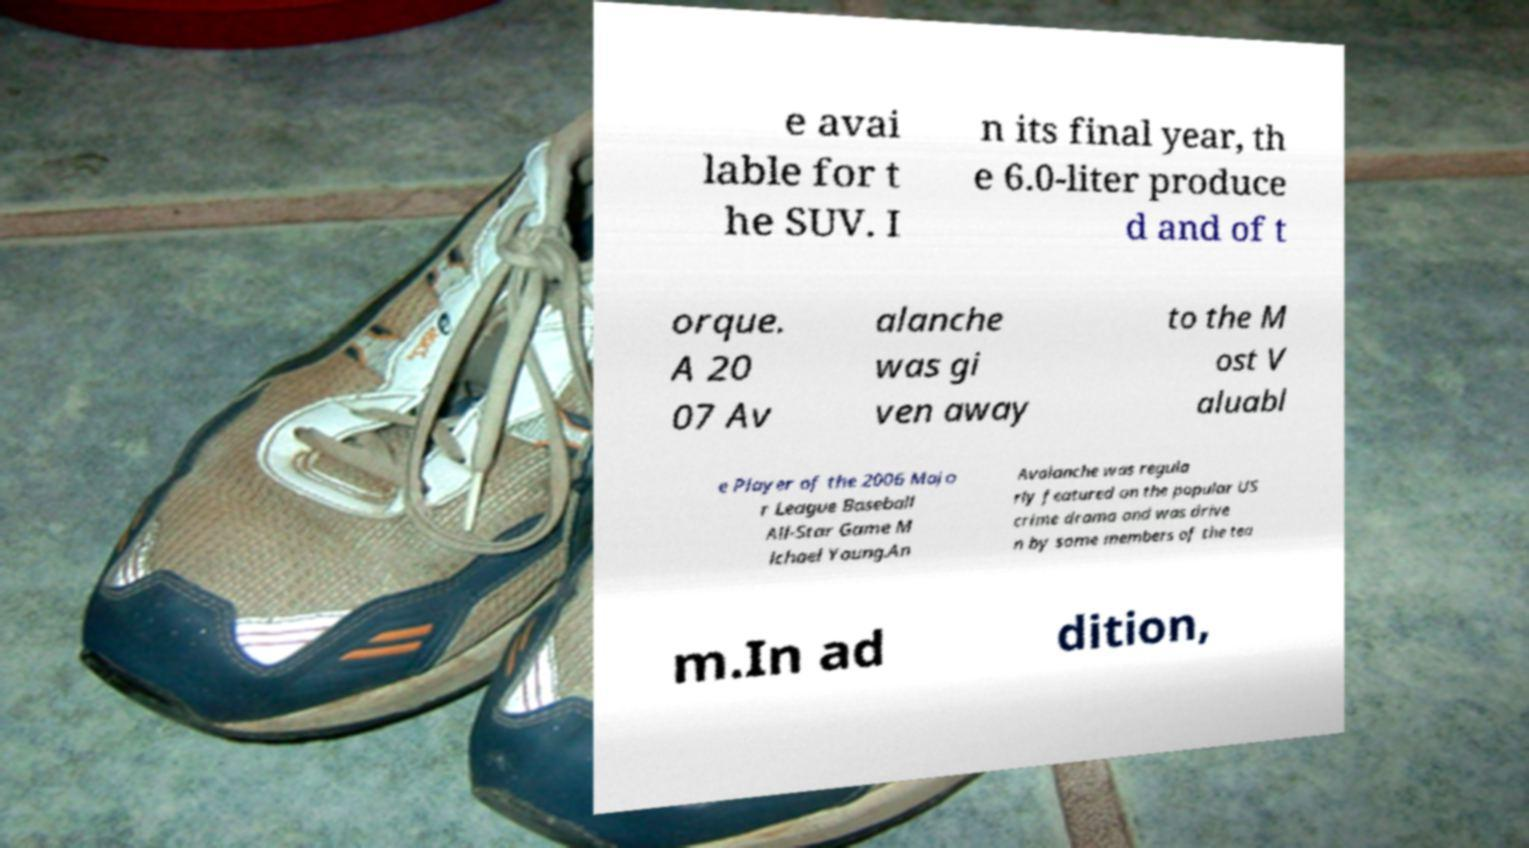What messages or text are displayed in this image? I need them in a readable, typed format. e avai lable for t he SUV. I n its final year, th e 6.0-liter produce d and of t orque. A 20 07 Av alanche was gi ven away to the M ost V aluabl e Player of the 2006 Majo r League Baseball All-Star Game M ichael Young.An Avalanche was regula rly featured on the popular US crime drama and was drive n by some members of the tea m.In ad dition, 